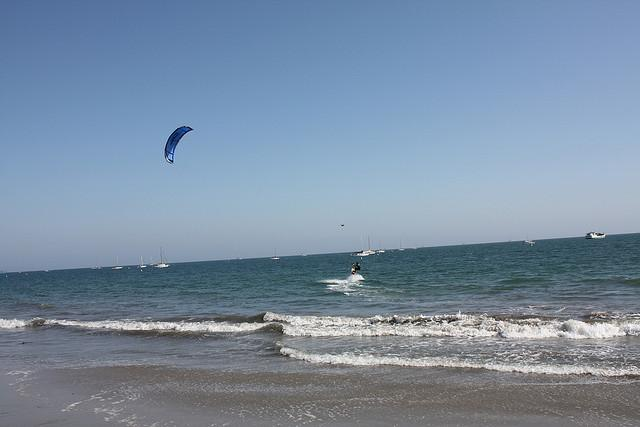The shape of the paragliding inflatable wing is?

Choices:
A) round
B) circular
C) triangle
D) elliptical elliptical 